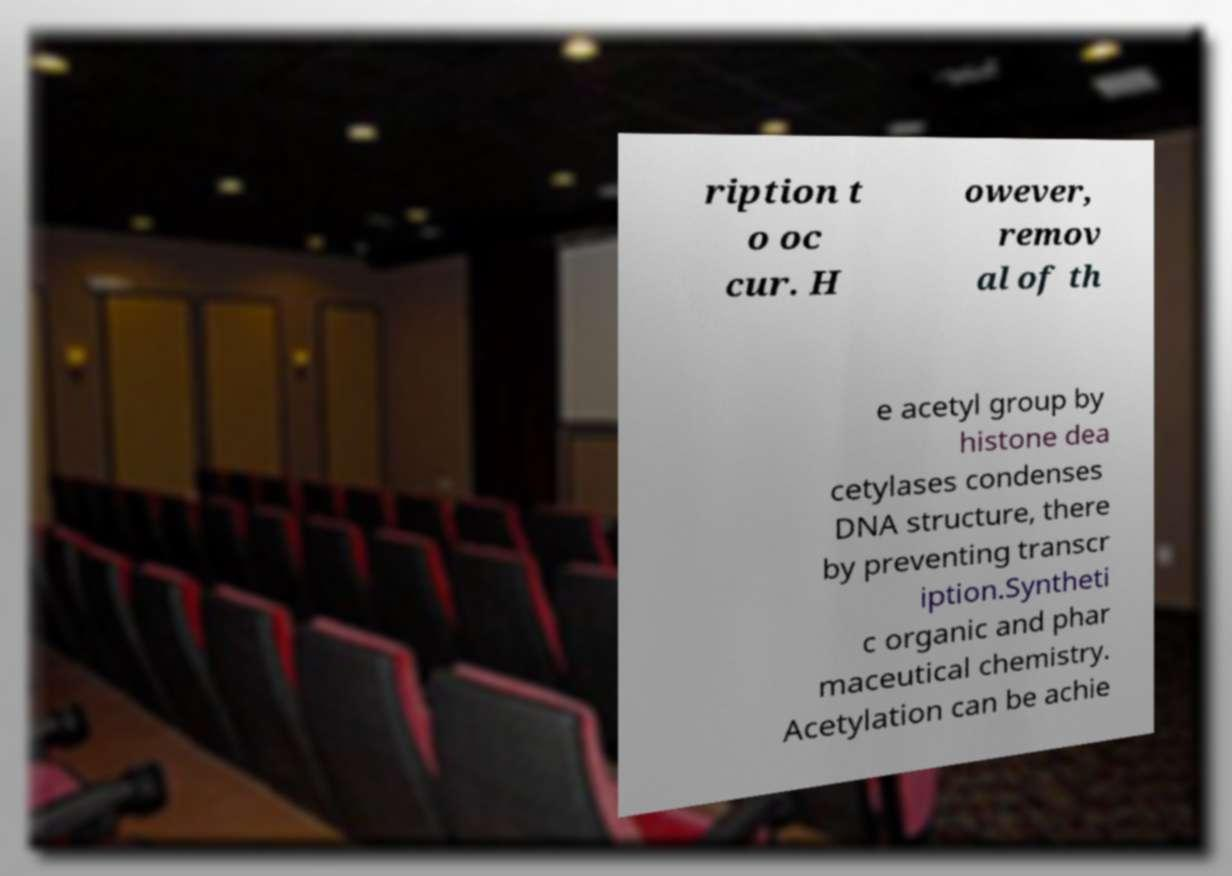Could you assist in decoding the text presented in this image and type it out clearly? ription t o oc cur. H owever, remov al of th e acetyl group by histone dea cetylases condenses DNA structure, there by preventing transcr iption.Syntheti c organic and phar maceutical chemistry. Acetylation can be achie 